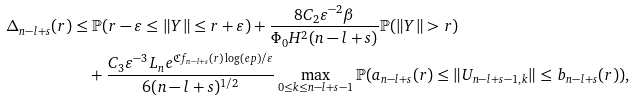<formula> <loc_0><loc_0><loc_500><loc_500>\Delta _ { n - l + s } ( r ) & \leq \mathbb { P } ( r - \varepsilon \leq \| Y \| \leq r + \varepsilon ) + \frac { 8 C _ { 2 } \varepsilon ^ { - 2 } \beta } { \Phi _ { 0 } H ^ { 2 } ( n - l + s ) } \mathbb { P } ( \| Y \| > r ) \\ & \quad + \frac { C _ { 3 } \varepsilon ^ { - 3 } L _ { n } e ^ { \mathfrak { C } f _ { n - l + s } ( r ) \log ( e p ) / \varepsilon } } { 6 ( n - l + s ) ^ { 1 / 2 } } \max _ { 0 \leq k \leq n - l + s - 1 } \mathbb { P } ( a _ { n - l + s } ( r ) \leq \| U _ { n - l + s - 1 , k } \| \leq b _ { n - l + s } ( r ) ) ,</formula> 